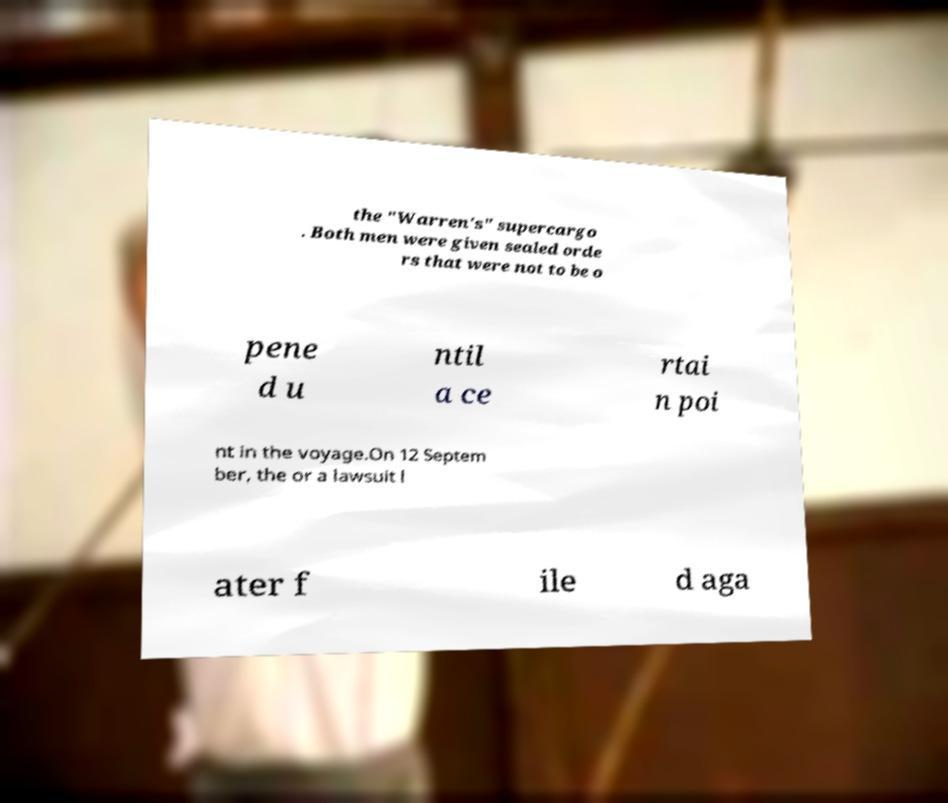What messages or text are displayed in this image? I need them in a readable, typed format. the "Warren's" supercargo . Both men were given sealed orde rs that were not to be o pene d u ntil a ce rtai n poi nt in the voyage.On 12 Septem ber, the or a lawsuit l ater f ile d aga 